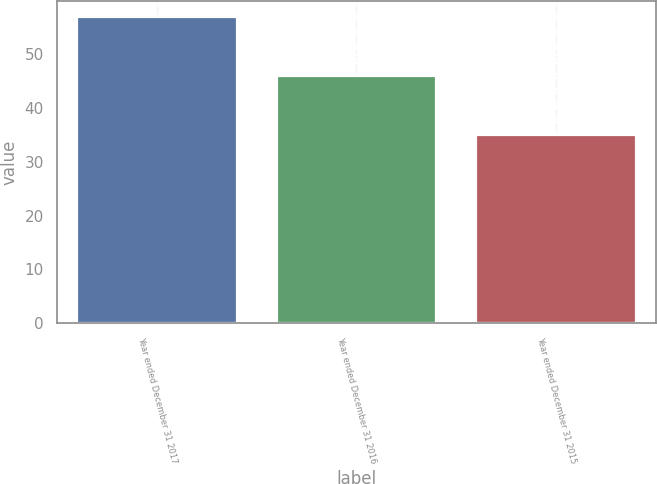Convert chart to OTSL. <chart><loc_0><loc_0><loc_500><loc_500><bar_chart><fcel>Year ended December 31 2017<fcel>Year ended December 31 2016<fcel>Year ended December 31 2015<nl><fcel>57<fcel>46<fcel>35<nl></chart> 